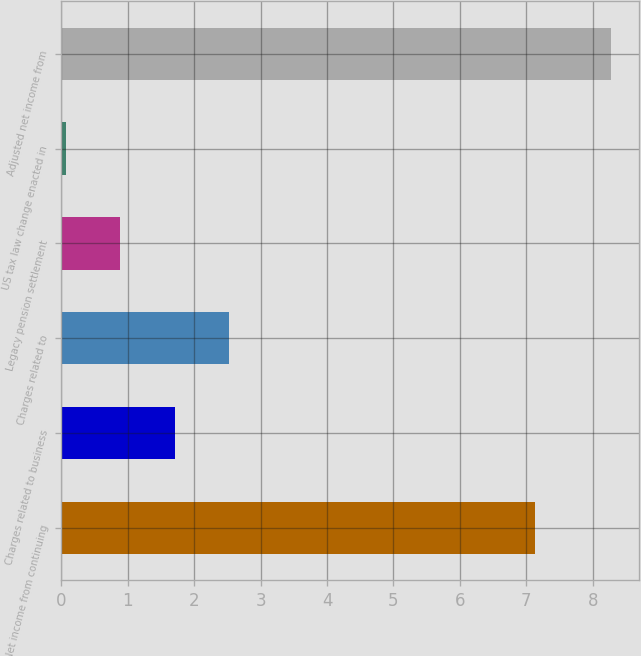Convert chart. <chart><loc_0><loc_0><loc_500><loc_500><bar_chart><fcel>Net income from continuing<fcel>Charges related to business<fcel>Charges related to<fcel>Legacy pension settlement<fcel>US tax law change enacted in<fcel>Adjusted net income from<nl><fcel>7.13<fcel>1.71<fcel>2.53<fcel>0.89<fcel>0.07<fcel>8.28<nl></chart> 